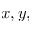Convert formula to latex. <formula><loc_0><loc_0><loc_500><loc_500>x , y ,</formula> 